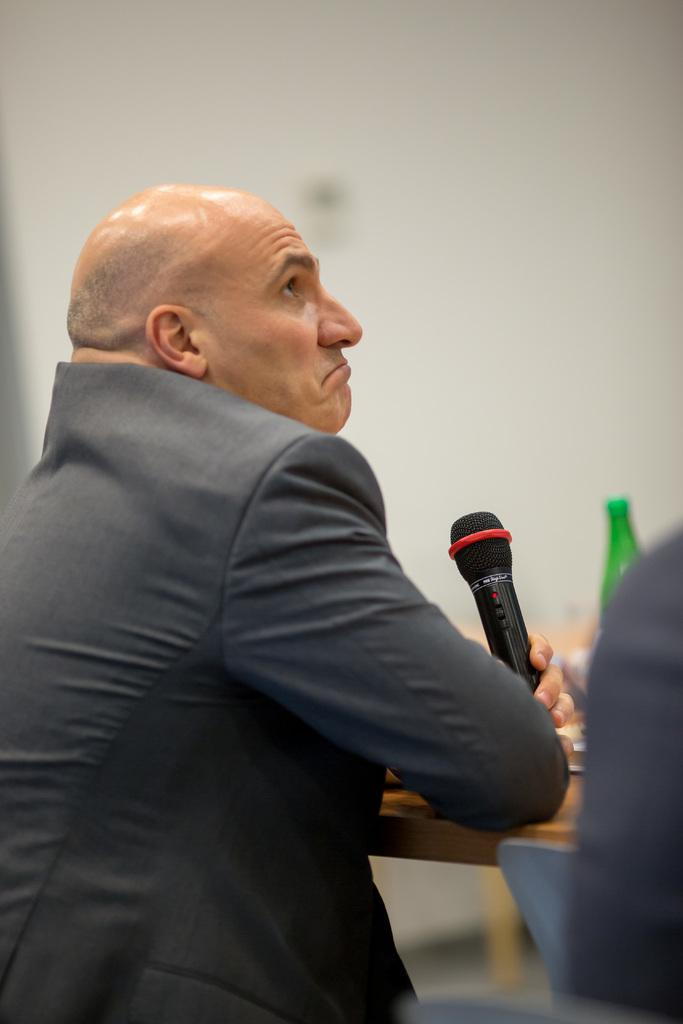Who is present in the image? There is a man in the image. What is the man wearing? The man is wearing a suit. What object is the man holding in his hand? The man is holding a microphone in his hand. What type of tomatoes can be seen in the market in the image? There is no market or tomatoes present in the image; it features a man wearing a suit and holding a microphone. 